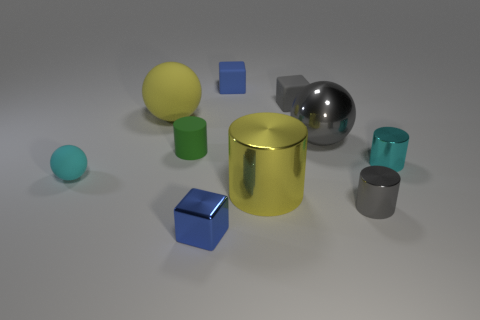There is a rubber block that is the same color as the large metal ball; what size is it?
Offer a terse response. Small. Are there any green rubber cylinders behind the blue rubber block?
Make the answer very short. No. What number of other things are there of the same shape as the yellow shiny object?
Your response must be concise. 3. There is another rubber cylinder that is the same size as the cyan cylinder; what color is it?
Offer a terse response. Green. Are there fewer big cylinders that are to the left of the big yellow metallic cylinder than blue rubber cubes that are to the right of the big yellow matte thing?
Offer a terse response. Yes. There is a small cyan object that is on the left side of the big gray object that is behind the yellow metallic thing; how many big metallic cylinders are behind it?
Provide a succinct answer. 0. What size is the gray metallic thing that is the same shape as the small green matte object?
Provide a succinct answer. Small. Is there anything else that has the same size as the green cylinder?
Your response must be concise. Yes. Are there fewer cyan balls left of the tiny cyan cylinder than tiny cyan cylinders?
Offer a very short reply. No. Is the shape of the cyan matte thing the same as the tiny blue matte thing?
Provide a succinct answer. No. 